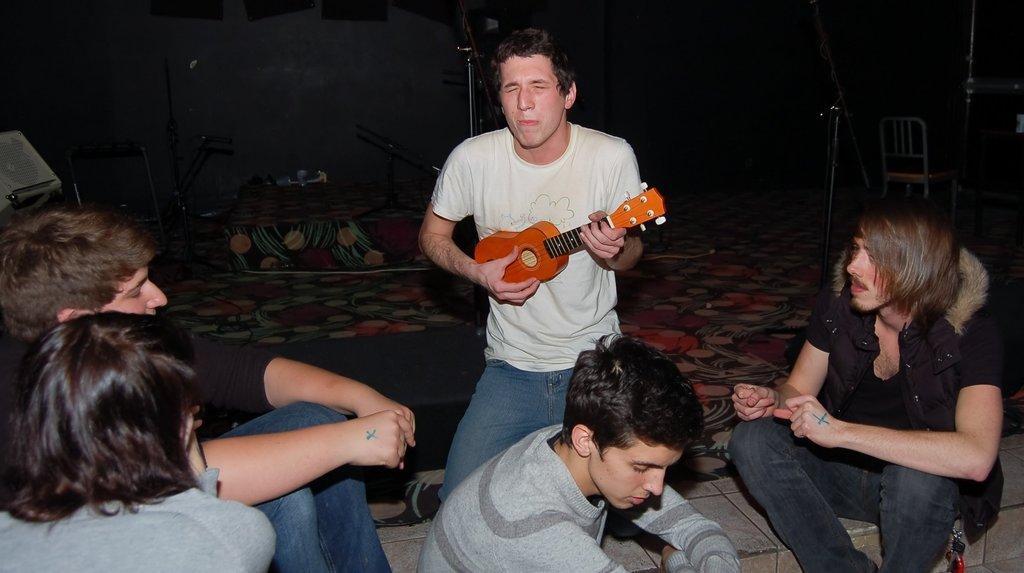Describe this image in one or two sentences. In the middle there is a man he is playing guitar ,he wear white t shirt and trouser. On the right there is a man he wear black shirt and trouser. On the left there are two people ,staring at something. In the background there is a stand and chair. 